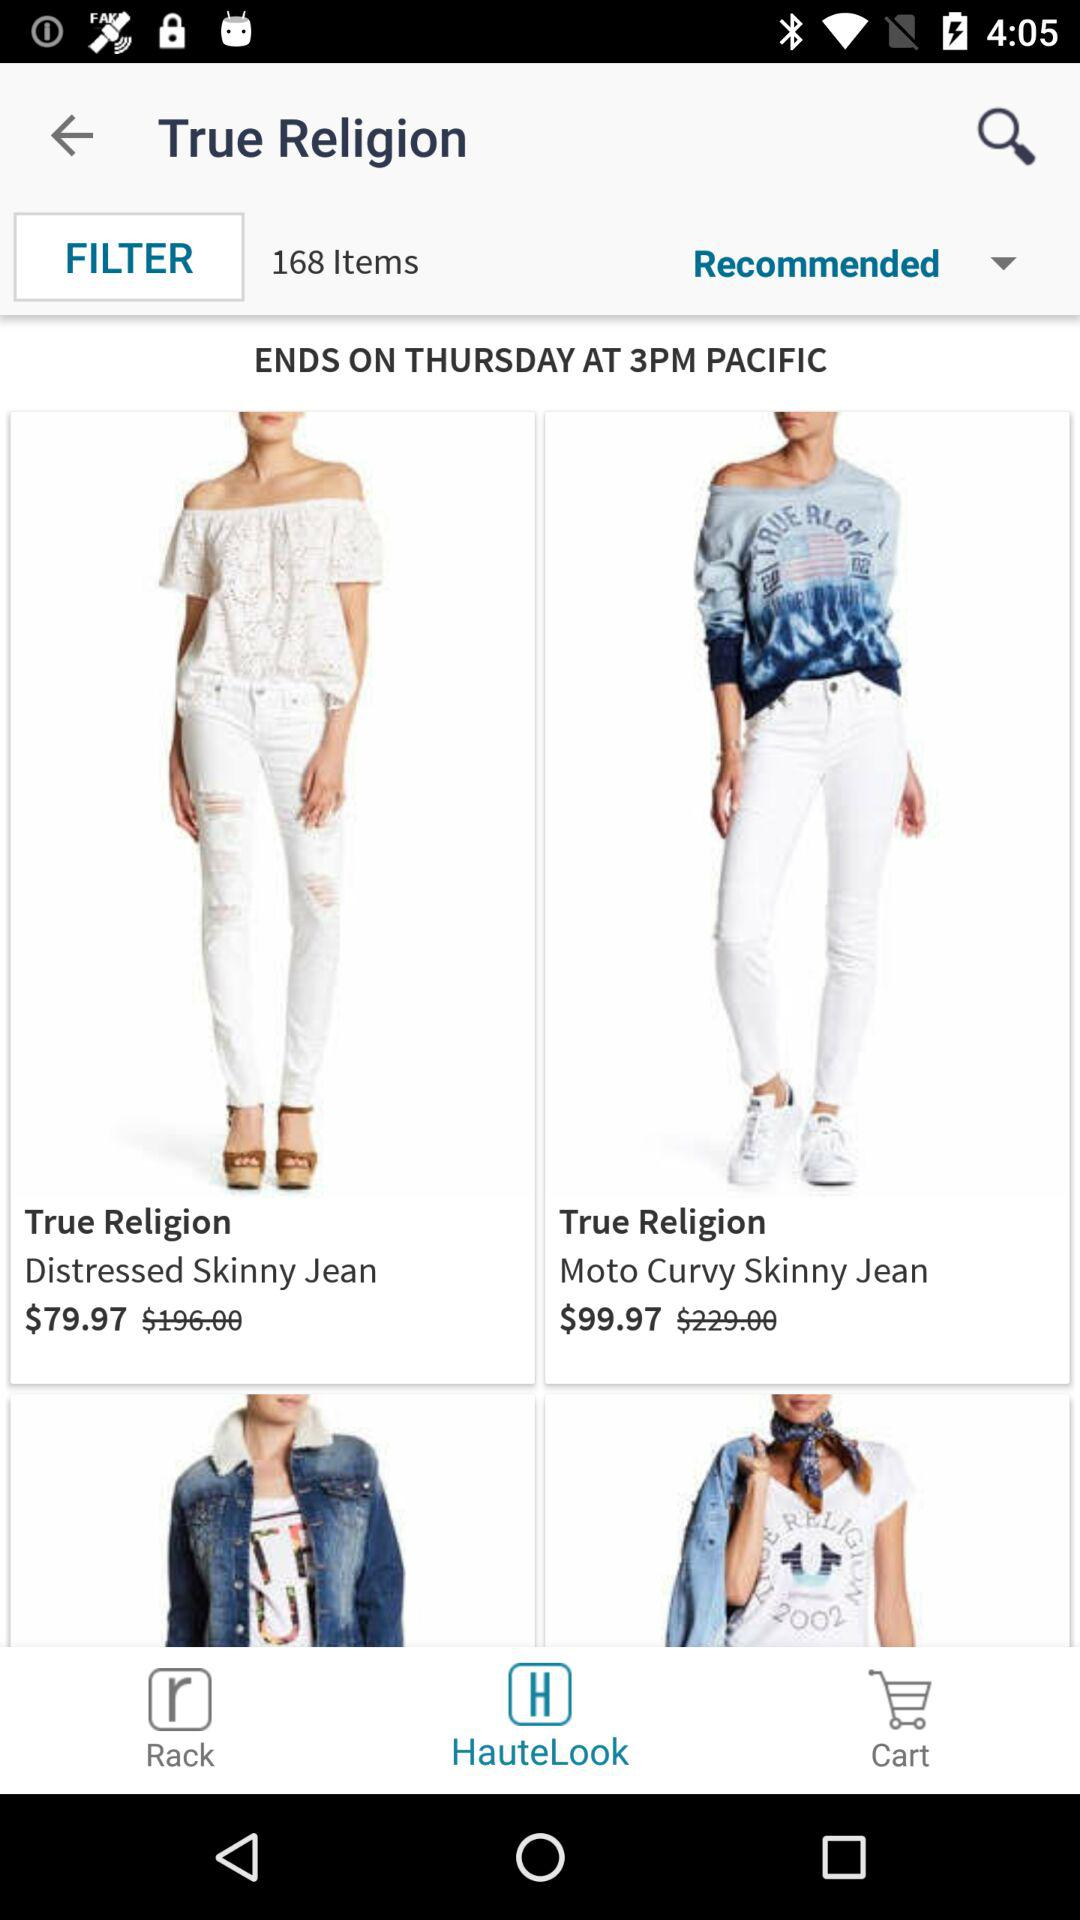On what day does the sale end? The sale ends on Thursday. 